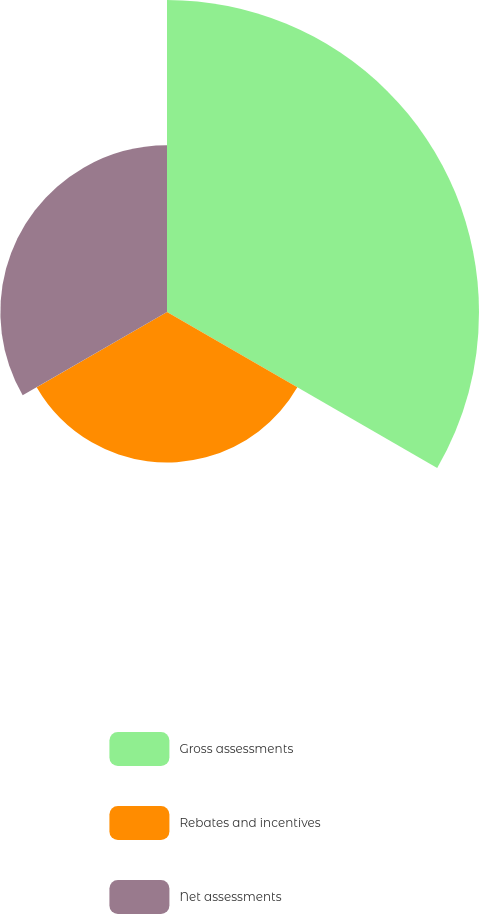<chart> <loc_0><loc_0><loc_500><loc_500><pie_chart><fcel>Gross assessments<fcel>Rebates and incentives<fcel>Net assessments<nl><fcel>49.59%<fcel>23.92%<fcel>26.49%<nl></chart> 